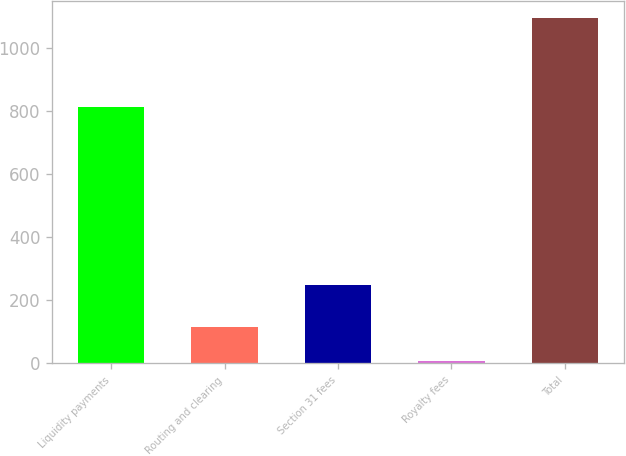Convert chart to OTSL. <chart><loc_0><loc_0><loc_500><loc_500><bar_chart><fcel>Liquidity payments<fcel>Routing and clearing<fcel>Section 31 fees<fcel>Royalty fees<fcel>Total<nl><fcel>813.9<fcel>117.06<fcel>248.2<fcel>8.2<fcel>1096.8<nl></chart> 